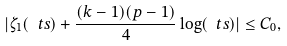Convert formula to latex. <formula><loc_0><loc_0><loc_500><loc_500>| \zeta _ { 1 } ( \ t s ) + \frac { ( k - 1 ) ( p - 1 ) } 4 \log ( \ t s ) | \leq C _ { 0 } ,</formula> 